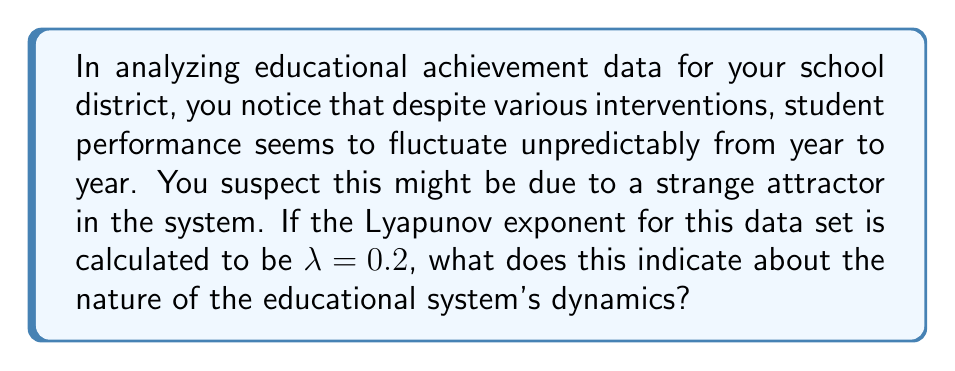What is the answer to this math problem? To understand the implications of the Lyapunov exponent in this context, let's break it down step-by-step:

1) The Lyapunov exponent ($\lambda$) is a measure of the rate at which nearby trajectories in a dynamical system diverge or converge.

2) In this case, $\lambda = 0.2$, which is a positive value.

3) A positive Lyapunov exponent indicates exponential divergence of nearby trajectories, which is a key characteristic of chaotic systems.

4) The magnitude of $\lambda$ tells us about the time scale of this divergence. We can calculate the time for two nearby points to diverge by a factor of $e$ (Euler's number) using the formula:

   $$T = \frac{1}{\lambda}$$

5) In this case:
   
   $$T = \frac{1}{0.2} = 5$$

6) This means that, on average, two initially close states in the system will diverge by a factor of $e$ every 5 time units (e.g., years in this educational context).

7) The presence of a strange attractor is further supported by this positive Lyapunov exponent, as strange attractors are typically associated with chaotic systems.

8) In the context of educational achievement, this suggests that small changes in initial conditions (e.g., slight differences in teaching methods, resources, or student populations) can lead to significantly different outcomes over time.

9) However, the system is not purely random. The strange attractor implies that while the system's behavior is unpredictable in detail, it still follows certain patterns or constraints.

10) This chaotic behavior could explain why educational interventions might have unpredictable effects, and why achievement levels fluctuate despite consistent efforts to improve them.
Answer: The positive Lyapunov exponent ($\lambda = 0.2$) indicates chaotic dynamics in the educational system, characterized by sensitive dependence on initial conditions and the likely presence of a strange attractor. 